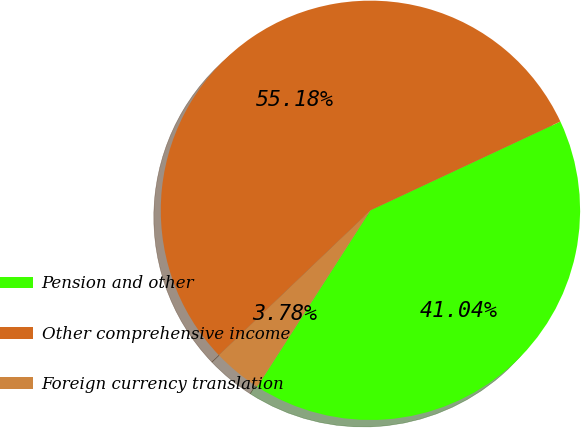Convert chart to OTSL. <chart><loc_0><loc_0><loc_500><loc_500><pie_chart><fcel>Pension and other<fcel>Other comprehensive income<fcel>Foreign currency translation<nl><fcel>41.04%<fcel>55.18%<fcel>3.78%<nl></chart> 